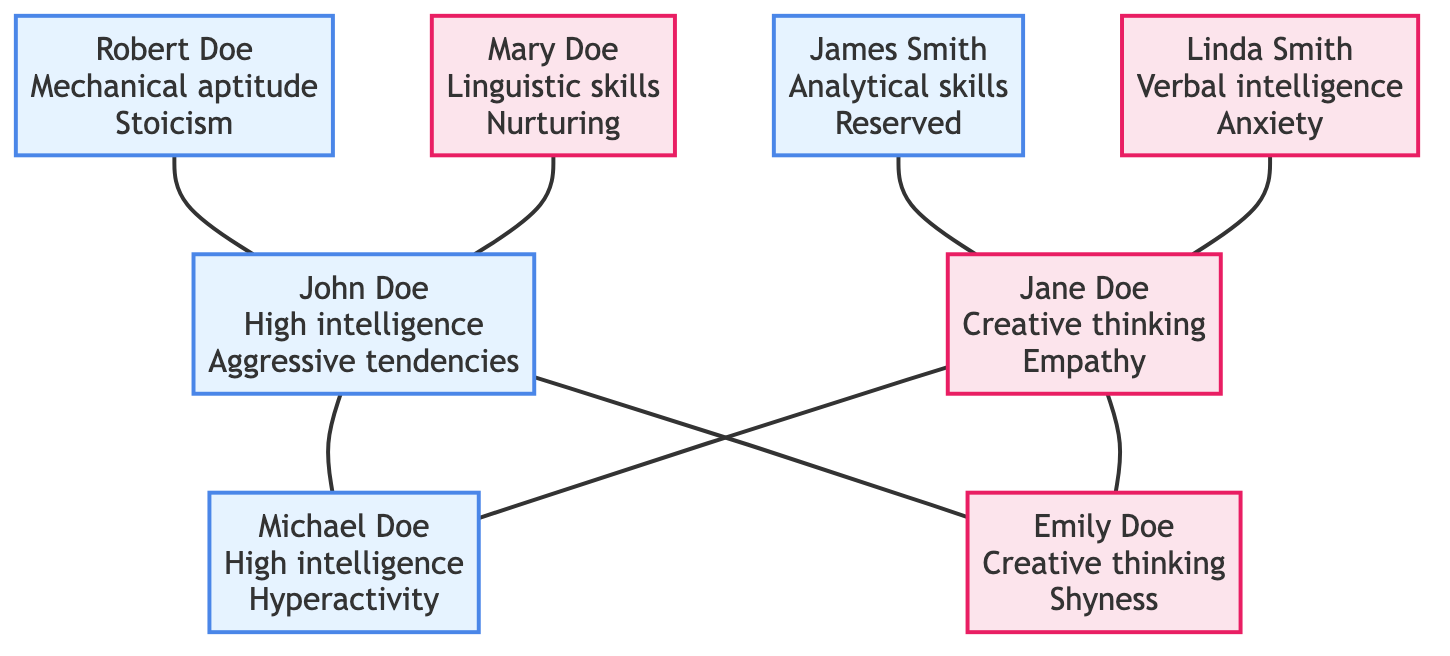What are the cognitive traits of John Doe? According to the diagram, John Doe has two cognitive traits listed: "high intelligence" and "logical thinker". These traits are directly linked to his node.
Answer: high intelligence, logical thinker Who is the father of Emily Doe? The relationship shown in the diagram indicates that John Doe is connected to Emily Doe as her father. This connection points directly to his node without ambiguity.
Answer: John Doe How many children are there in the family tree? By examining the children nodes connected to the parents, we see two children: Michael and Emily Doe. Therefore, the count of children nodes connected to the parent node is two.
Answer: 2 What are the behavioral traits of Jane Doe? The behavioral traits associated with Jane Doe listed in the diagram include "empathy" and "anxiety". These specific traits are indicated in her node.
Answer: empathy, anxiety Which grandparent has the trait of workaholism? Looking through the grandparents’ nodes, the trait of "workaholism" is associated with Robert Doe. His direct node shows this trait, confirming his relation to John Doe as the paternal grandfather.
Answer: Robert Doe Which grandchild has high intelligence? The diagram indicates that Michael Doe, as a child of John and Jane Doe, possesses the cognitive trait of "high intelligence" as shown in his node.
Answer: Michael Doe What is the relationship between Mary Doe and John Doe? The diagram connects Mary Doe as John Doe's mother, establishing a direct familial relationship as it explicitly shows her as the maternal line grandparent.
Answer: Mother How many grandmothers are mentioned in the family tree? By analyzing the nodes for grandparents, we find two grandmothers: Mary Doe and Linda Smith, which totals to two distinct grandmothers noted in the diagram.
Answer: 2 What behavioral trait do both Emily and Michael share? By examining the behavioral traits of both children, it becomes clear that neither has the same trait; however, both share a tendency towards anxiety stemming from their mother, Jane Doe's lineage. This connection goes back to the traits associated with their parents.
Answer: None (they do not share a specific behavioral trait directly) 